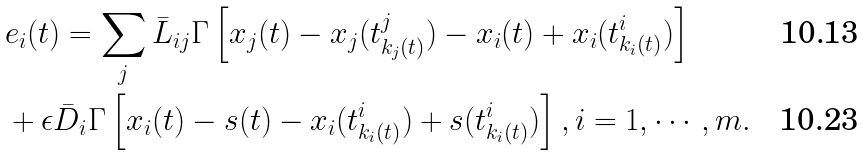Convert formula to latex. <formula><loc_0><loc_0><loc_500><loc_500>& e _ { i } ( t ) = \sum _ { j } \bar { L } _ { i j } \Gamma \left [ x _ { j } ( t ) - x _ { j } ( t _ { k _ { j } ( t ) } ^ { j } ) - x _ { i } ( t ) + x _ { i } ( t _ { k _ { i } ( t ) } ^ { i } ) \right ] \\ & + \epsilon \bar { D } _ { i } \Gamma \left [ x _ { i } ( t ) - s ( t ) - x _ { i } ( t _ { k _ { i } ( t ) } ^ { i } ) + s ( t _ { k _ { i } ( t ) } ^ { i } ) \right ] , i = 1 , \cdots , m .</formula> 